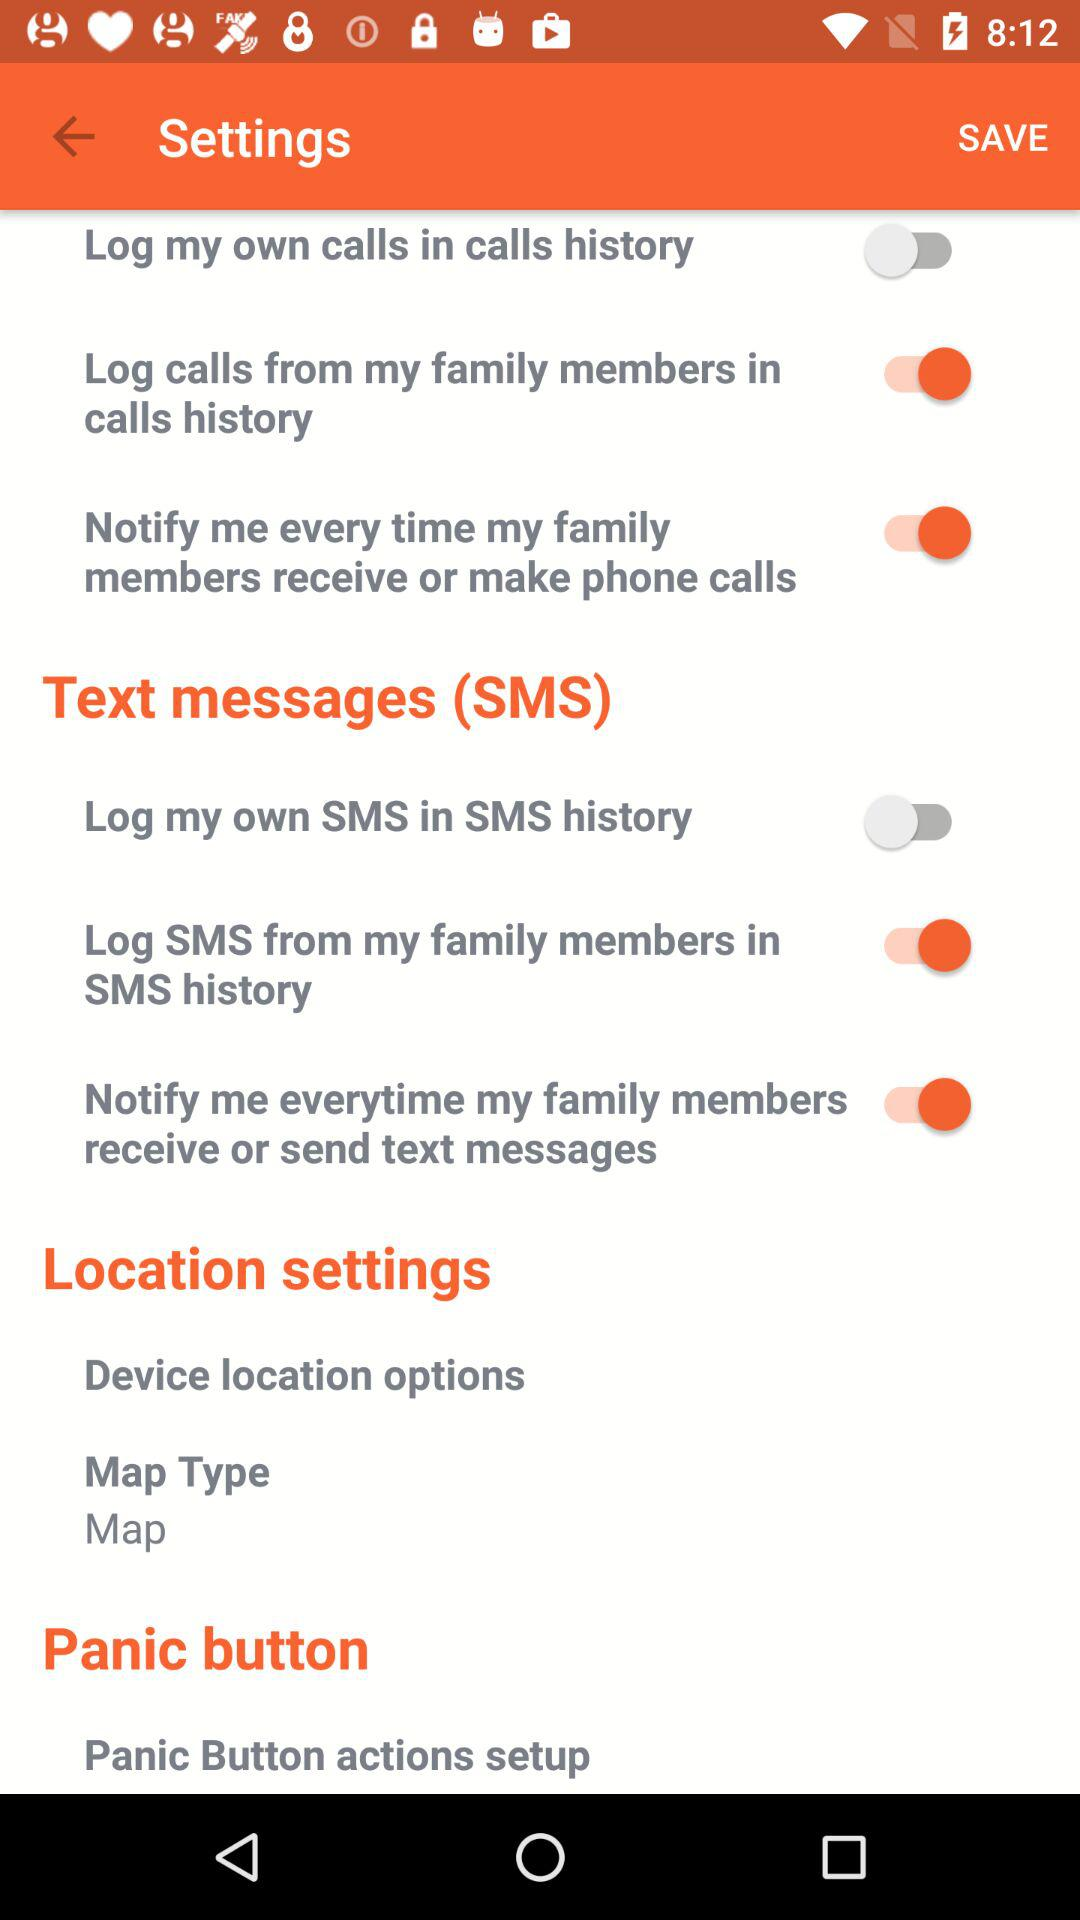Is "Log my own calls in calls history" on or off? The status is "off". 